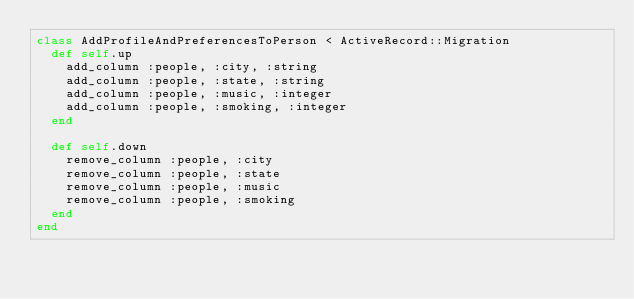<code> <loc_0><loc_0><loc_500><loc_500><_Ruby_>class AddProfileAndPreferencesToPerson < ActiveRecord::Migration
  def self.up
    add_column :people, :city, :string
    add_column :people, :state, :string
    add_column :people, :music, :integer
    add_column :people, :smoking, :integer
  end

  def self.down
    remove_column :people, :city
    remove_column :people, :state
    remove_column :people, :music
    remove_column :people, :smoking
  end
end
</code> 